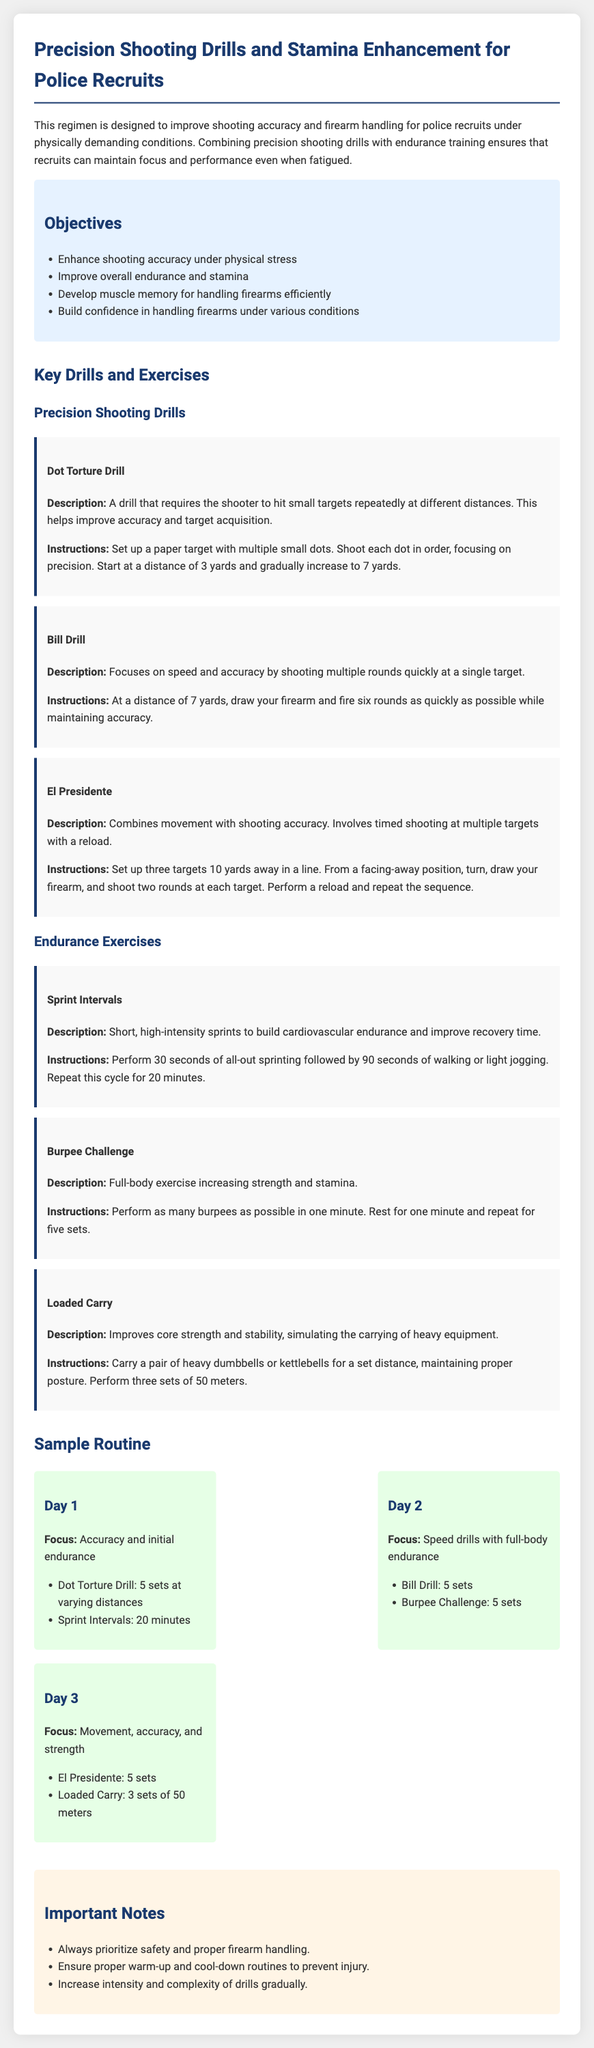what is the title of the document? The title of the document is specified in the head section of the HTML code.
Answer: Police Recruit Precision Shooting & Stamina Workout Plan how many key drills are listed under Precision Shooting Drills? The document outlines three key drills under the Precision Shooting Drills section.
Answer: 3 what is the duration for the Sprint Intervals exercise? The document specifies that Sprint Intervals should be performed for 20 minutes.
Answer: 20 minutes what is the primary focus of Day 2 in the Sample Routine? The primary focus is stated directly in the Day 2 section of the Sample Routine.
Answer: Speed drills with full-body endurance what does the Burpee Challenge aim to improve? The improvement focus is mentioned in the description of the Burpee Challenge in the document.
Answer: Strength and stamina how many sets are performed for the Dot Torture Drill? The document indicates that 5 sets are performed for the Dot Torture Drill.
Answer: 5 sets what is the purpose of the Loaded Carry exercise? The purpose is mentioned in the description of the Loaded Carry exercise in the document.
Answer: Improve core strength and stability what should be prioritized according to the Important Notes section? The Important Notes section emphasizes the need stated within it about handling firearms.
Answer: Safety and proper firearm handling 